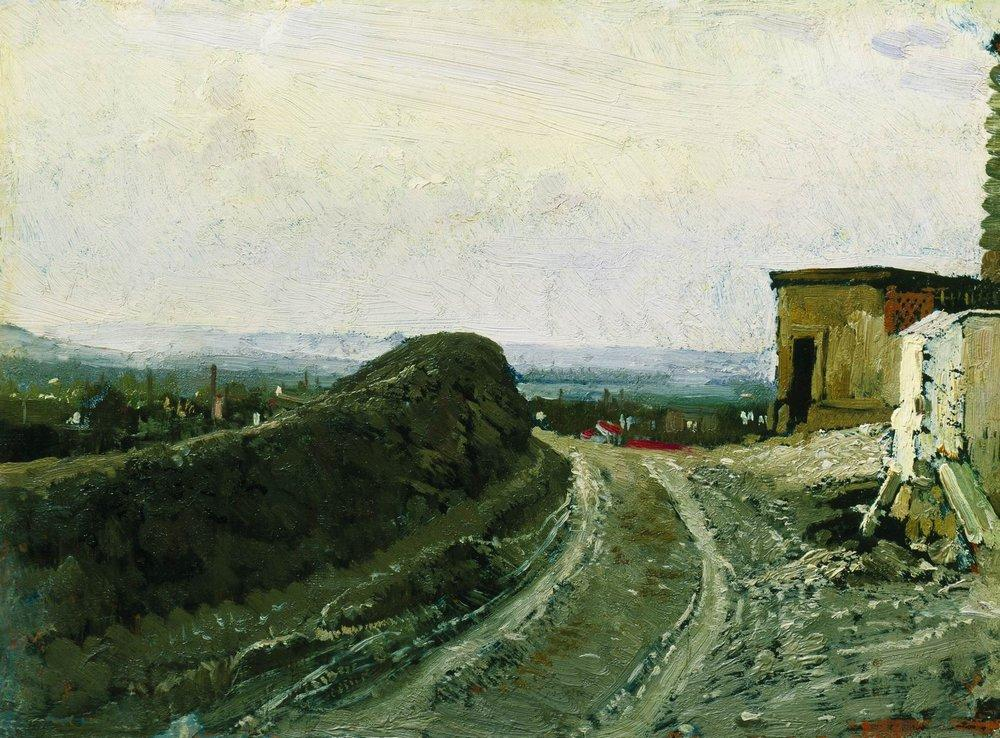How does the impressionist style influence the viewer’s perception of this landscape? The impressionist style of the painting, characterized by loose, dynamic brushstrokes and a focus on light and color, creates a sense of movement and spontaneity. This approach allows viewers to experience the landscape as though they are glimpsing it in a fleeting moment, enhancing the emotional impact and making the scene feel alive. It invites viewers to engage more personally with the image, filling in details with their imagination and experiencing the natural charm and vitality of the setting. 